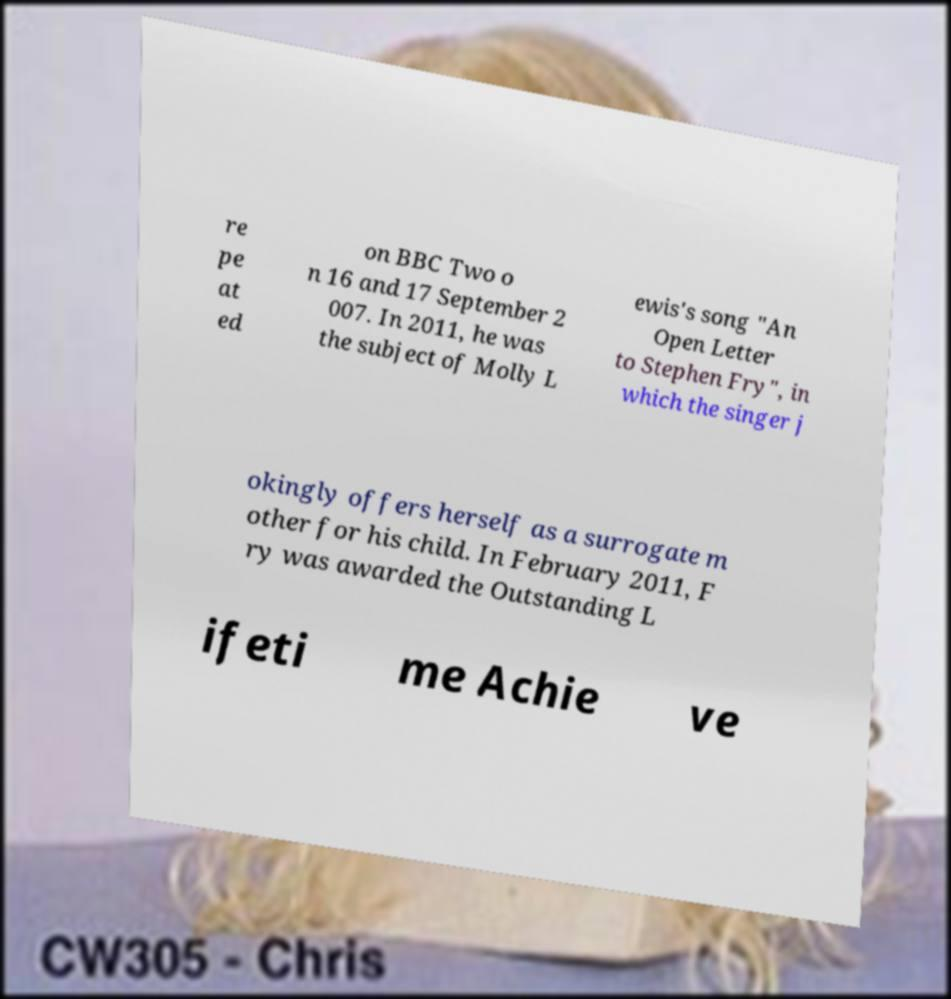Can you accurately transcribe the text from the provided image for me? re pe at ed on BBC Two o n 16 and 17 September 2 007. In 2011, he was the subject of Molly L ewis's song "An Open Letter to Stephen Fry", in which the singer j okingly offers herself as a surrogate m other for his child. In February 2011, F ry was awarded the Outstanding L ifeti me Achie ve 